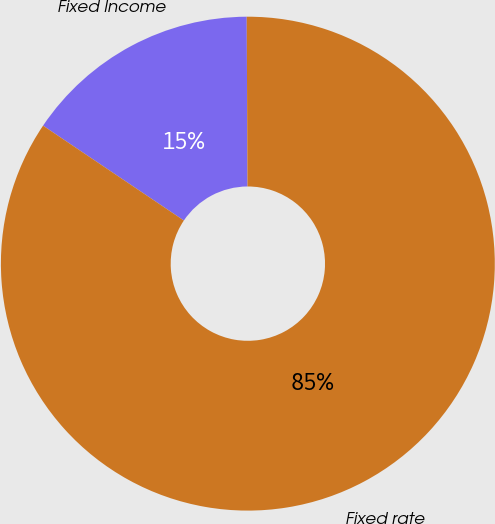Convert chart to OTSL. <chart><loc_0><loc_0><loc_500><loc_500><pie_chart><fcel>Fixed Income<fcel>Fixed rate<nl><fcel>15.49%<fcel>84.51%<nl></chart> 